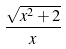Convert formula to latex. <formula><loc_0><loc_0><loc_500><loc_500>\frac { \sqrt { x ^ { 2 } + 2 } } { x }</formula> 